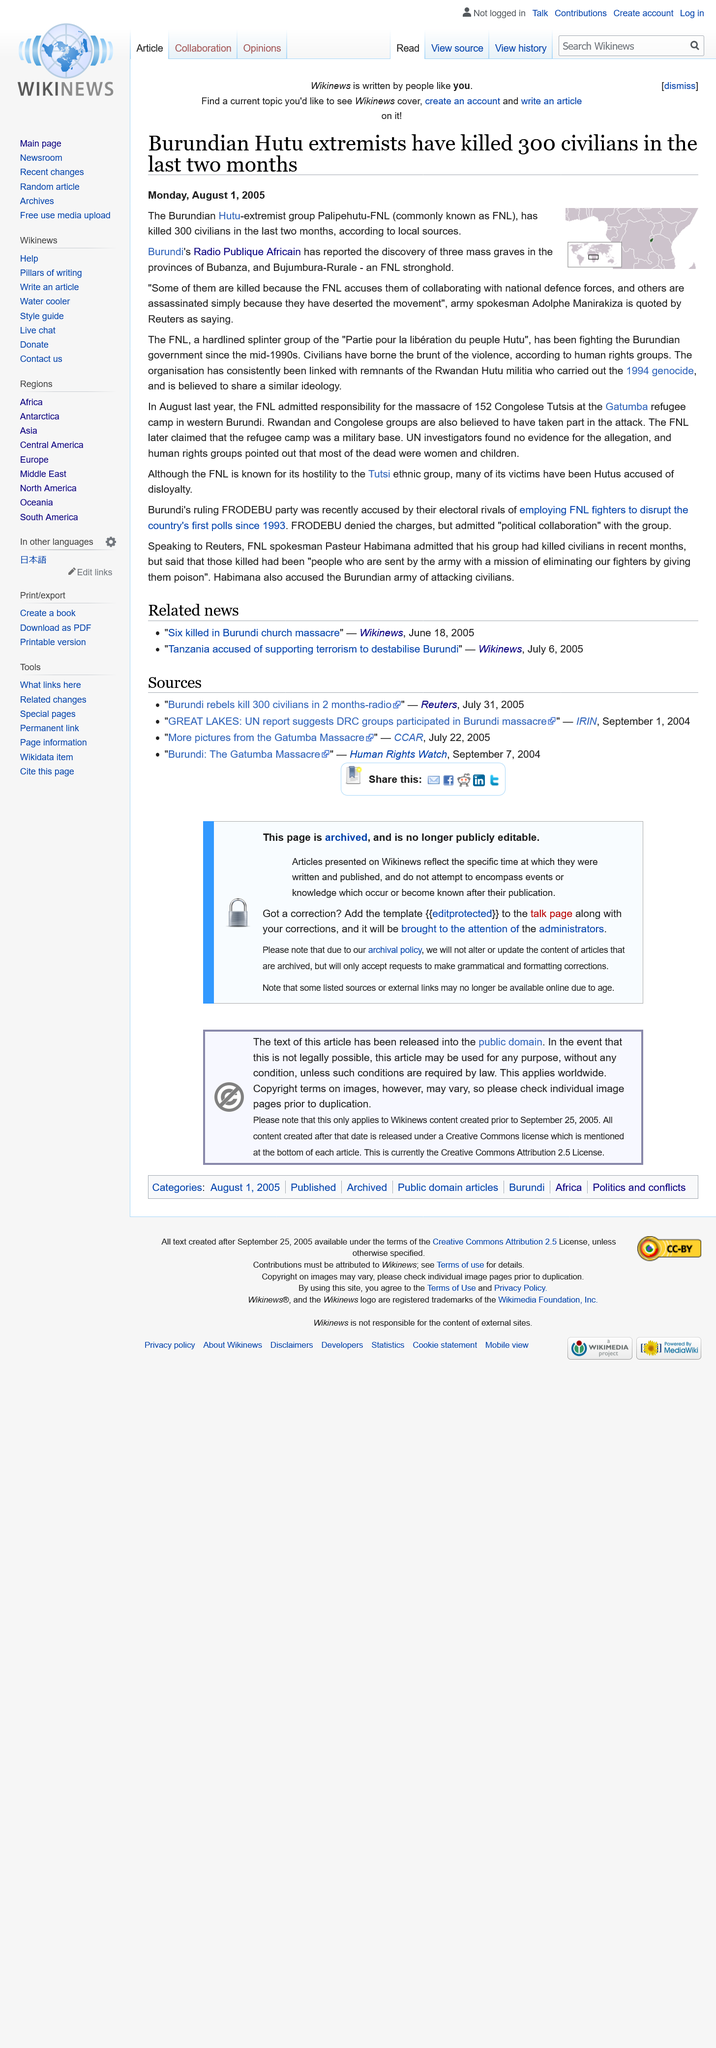Highlight a few significant elements in this photo. In the last two months, Palipehutu-FNL have killed 300 civilians, according to reliable sources. Thirty-three individuals were found buried in three mass graves in Bubanaza and Bujumbura-Rurale provinces. The Palipehutu-FNL have been engaged in conflict with the Burundian government. 